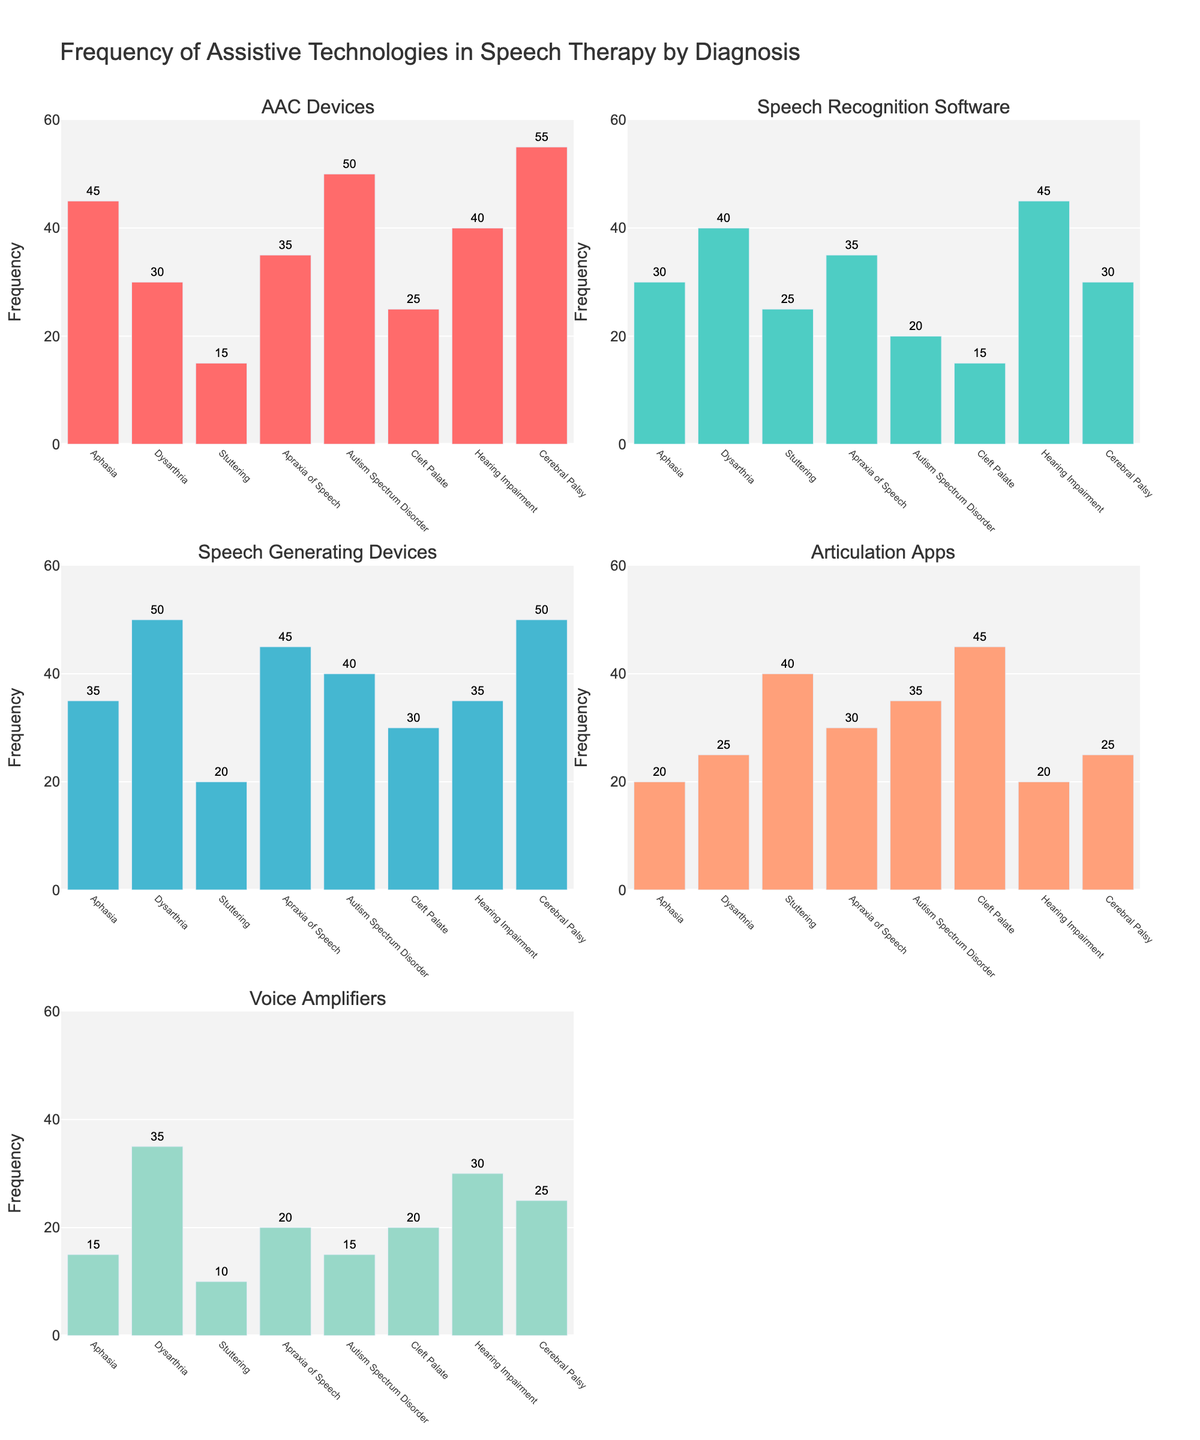Which assistive technology is used more frequently for Aphasia compared to Dysarthria? From the bar chart for each assistive technology, compare the values for Aphasia and Dysarthria. Aphasia has higher usage of AAC Devices (45 > 30) and Voice Amplifiers (15 > 35).
Answer: AAC Devices What is the highest frequency value observed across all subplots? Inspect each subplot and identify the highest value in any bar. The maximum frequency value is observed for Cerebral Palsy in the AAC Devices subplot with a value of 55.
Answer: 55 How does the usage of Speech Recognition Software for Hearing Impairment compare to that for Stuttering? Look at the bar corresponding to Hearing Impairment and Stuttering in the Speech Recognition Software subplot. Hearing Impairment has a value of 45, while Stuttering has a value of 25.
Answer: Higher for Hearing Impairment What is the average frequency of Voice Amplifiers used across all diagnoses? Add all the values for Voice Amplifiers and divide by the number of diagnoses (15 + 35 + 10 + 20 + 15 + 20 + 30 + 25) / 8 = 170 / 8.
Answer: 21.25 In which diagnosis category is the usage of Articulation Apps the highest? Identify the maximum bar height in the Articulation Apps subplot. The highest value is 45 for Cleft Palate.
Answer: Cleft Palate Which assistive technology shows the least variance in usage across all diagnoses? Calculate the variance in usage for each assistive technology across the diagnoses. The Speech Recognition Software values are relatively similar: {30, 40, 25, 35, 20, 15, 45, 30} with the least variance.
Answer: Speech Recognition Software How does the usage of Speech Generating Devices for Autism Spectrum Disorder compare to Apraxia of Speech? Autism Spectrum Disorder has a value of 40, while Apraxia of Speech has a value of 45 for Speech Generating Devices.
Answer: Lower for Autism Spectrum Disorder What is the sum of frequencies for Dysarthria across all assistive technologies? Sum the values of Dysarthria across all subplots. 30 (AAC Devices) + 40 (Speech Recognition Software) + 50 (Speech Generating Devices) + 25 (Articulation Apps) + 35 (Voice Amplifiers) = 180.
Answer: 180 Which Diagnosis has the lowest total usage of assistive technologies? Sum the values across all technologies for each diagnosis, and compare to find the lowest total. Stuttering: 15 + 25 + 20 + 40 + 10 = 110, which is the lowest total.
Answer: Stuttering What is the range of frequencies for Speech Generating Devices? The range is the difference between the highest and lowest frequency values in the Speech Generating Devices subplot. The highest value is 50 (Dysarthria and Cerebral Palsy) and the lowest is 20 (Stuttering). Thus, the range is 50 - 20.
Answer: 30 